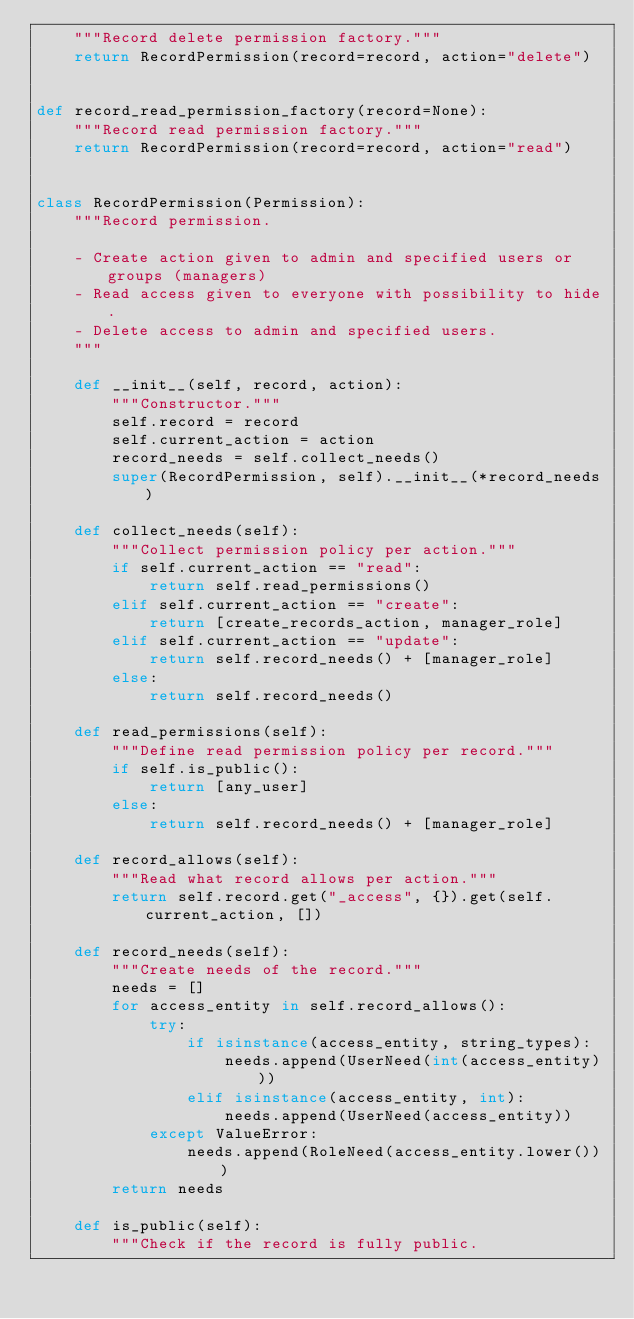<code> <loc_0><loc_0><loc_500><loc_500><_Python_>    """Record delete permission factory."""
    return RecordPermission(record=record, action="delete")


def record_read_permission_factory(record=None):
    """Record read permission factory."""
    return RecordPermission(record=record, action="read")


class RecordPermission(Permission):
    """Record permission.

    - Create action given to admin and specified users or groups (managers)
    - Read access given to everyone with possibility to hide.
    - Delete access to admin and specified users.
    """

    def __init__(self, record, action):
        """Constructor."""
        self.record = record
        self.current_action = action
        record_needs = self.collect_needs()
        super(RecordPermission, self).__init__(*record_needs)

    def collect_needs(self):
        """Collect permission policy per action."""
        if self.current_action == "read":
            return self.read_permissions()
        elif self.current_action == "create":
            return [create_records_action, manager_role]
        elif self.current_action == "update":
            return self.record_needs() + [manager_role]
        else:
            return self.record_needs()

    def read_permissions(self):
        """Define read permission policy per record."""
        if self.is_public():
            return [any_user]
        else:
            return self.record_needs() + [manager_role]

    def record_allows(self):
        """Read what record allows per action."""
        return self.record.get("_access", {}).get(self.current_action, [])

    def record_needs(self):
        """Create needs of the record."""
        needs = []
        for access_entity in self.record_allows():
            try:
                if isinstance(access_entity, string_types):
                    needs.append(UserNeed(int(access_entity)))
                elif isinstance(access_entity, int):
                    needs.append(UserNeed(access_entity))
            except ValueError:
                needs.append(RoleNeed(access_entity.lower()))
        return needs

    def is_public(self):
        """Check if the record is fully public.
</code> 